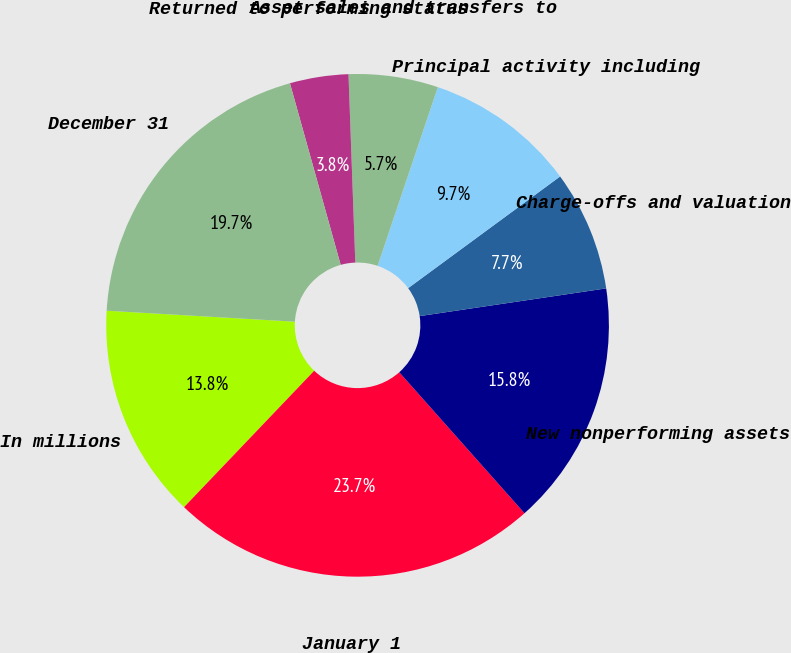Convert chart. <chart><loc_0><loc_0><loc_500><loc_500><pie_chart><fcel>In millions<fcel>January 1<fcel>New nonperforming assets<fcel>Charge-offs and valuation<fcel>Principal activity including<fcel>Asset sales and transfers to<fcel>Returned to performing status<fcel>December 31<nl><fcel>13.8%<fcel>23.69%<fcel>15.79%<fcel>7.74%<fcel>9.74%<fcel>5.75%<fcel>3.76%<fcel>19.74%<nl></chart> 